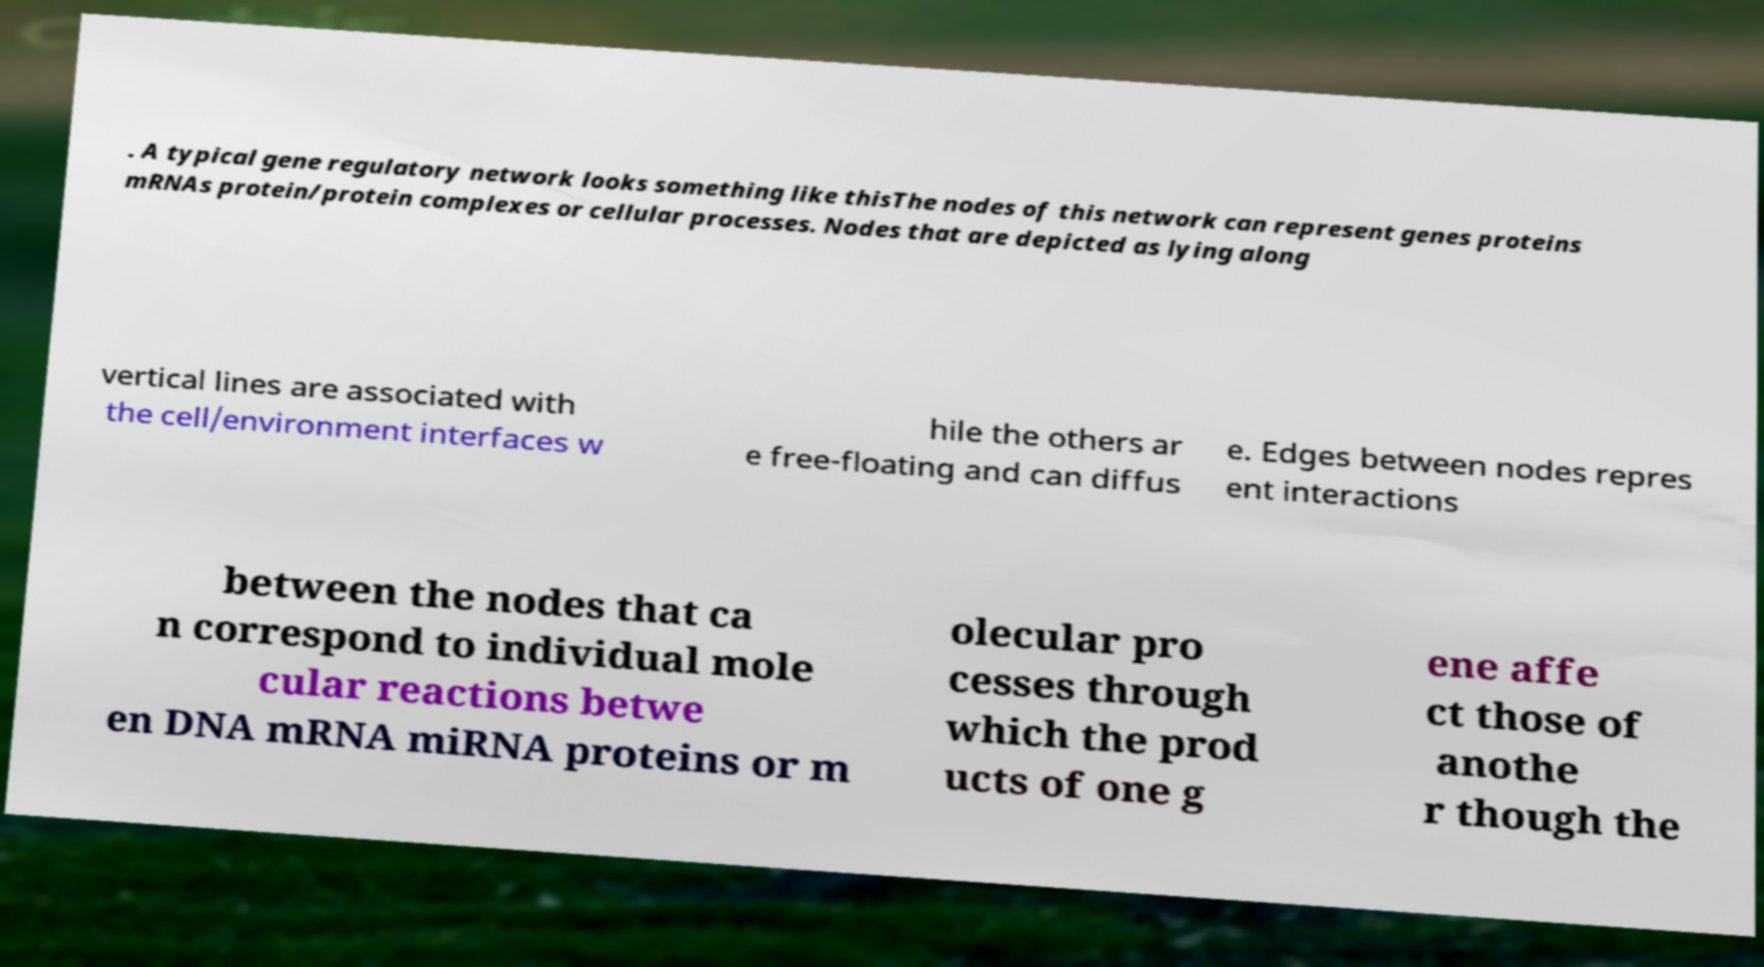For documentation purposes, I need the text within this image transcribed. Could you provide that? . A typical gene regulatory network looks something like thisThe nodes of this network can represent genes proteins mRNAs protein/protein complexes or cellular processes. Nodes that are depicted as lying along vertical lines are associated with the cell/environment interfaces w hile the others ar e free-floating and can diffus e. Edges between nodes repres ent interactions between the nodes that ca n correspond to individual mole cular reactions betwe en DNA mRNA miRNA proteins or m olecular pro cesses through which the prod ucts of one g ene affe ct those of anothe r though the 